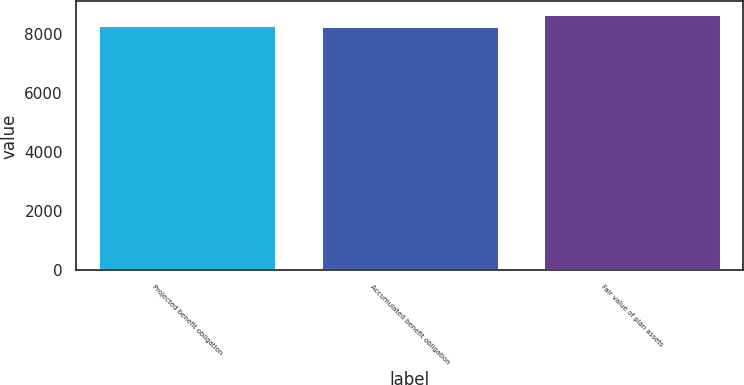Convert chart to OTSL. <chart><loc_0><loc_0><loc_500><loc_500><bar_chart><fcel>Projected benefit obligation<fcel>Accumulated benefit obligation<fcel>Fair value of plan assets<nl><fcel>8324.1<fcel>8285<fcel>8676<nl></chart> 